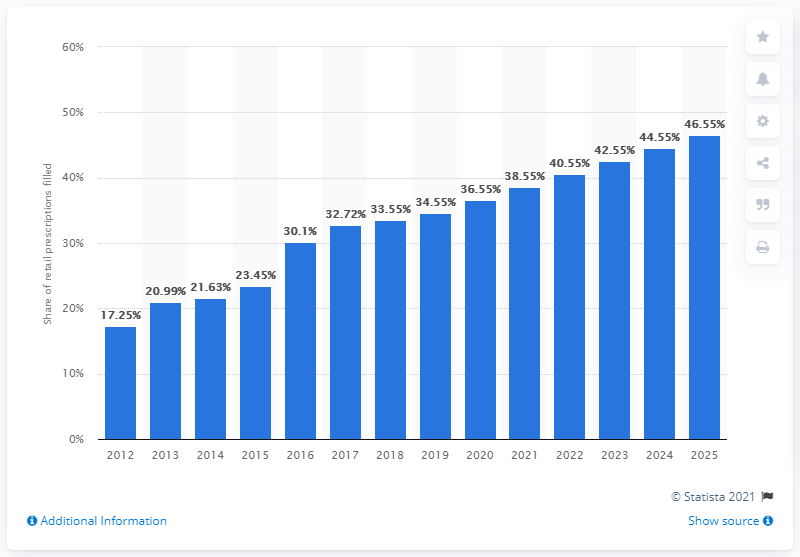Outline some significant characteristics in this image. According to projections for 2019, CVS Caremark is expected to be responsible for approximately 34.55% of retail prescriptions. 